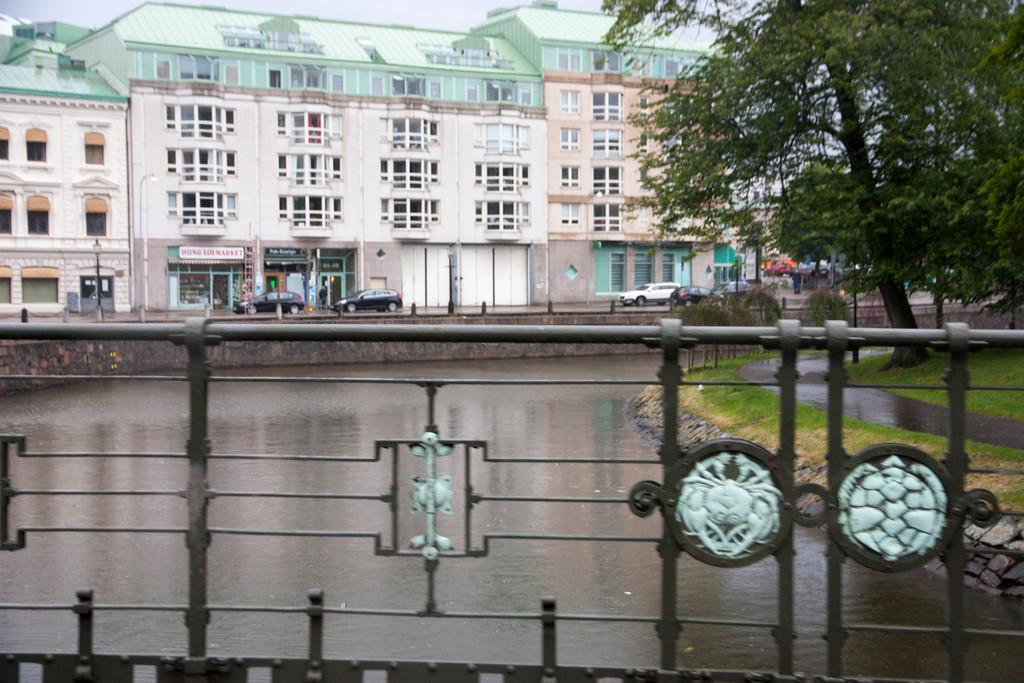What is the primary element visible in the image? There is water in the image. What type of vegetation is present on the ground? The ground is covered with grass. What other natural elements can be seen in the image? There are trees in the image. What man-made structures are visible in the image? Cars are parked on the road, and there are buildings in the background. Can you see any clams in the water in the image? There are no clams visible in the water in the image. What color is the sky in the image? The provided facts do not mention the sky, so we cannot determine its color from the image. 